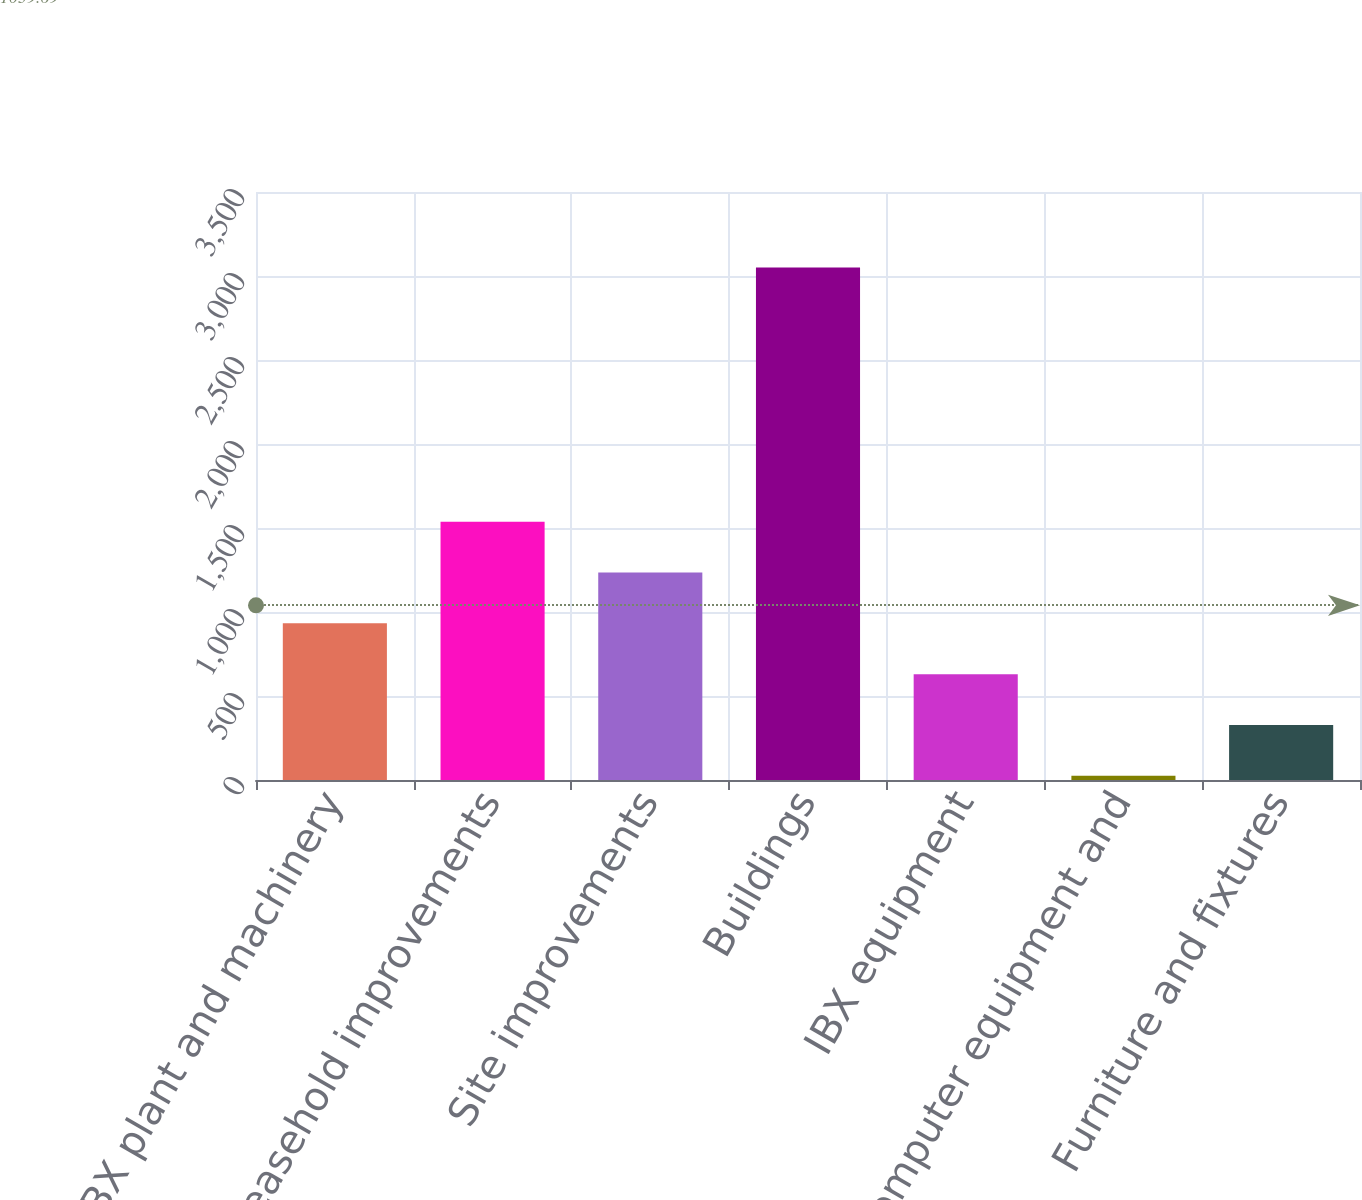<chart> <loc_0><loc_0><loc_500><loc_500><bar_chart><fcel>IBX plant and machinery<fcel>Leasehold improvements<fcel>Site improvements<fcel>Buildings<fcel>IBX equipment<fcel>Computer equipment and<fcel>Furniture and fixtures<nl><fcel>932.5<fcel>1537.5<fcel>1235<fcel>3050<fcel>630<fcel>25<fcel>327.5<nl></chart> 